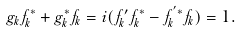Convert formula to latex. <formula><loc_0><loc_0><loc_500><loc_500>g _ { k } f _ { k } ^ { * } + g _ { k } ^ { * } f _ { k } = i ( f ^ { \prime } _ { k } f _ { k } ^ { * } - f ^ { ^ { \prime } * } _ { k } f _ { k } ) = 1 .</formula> 